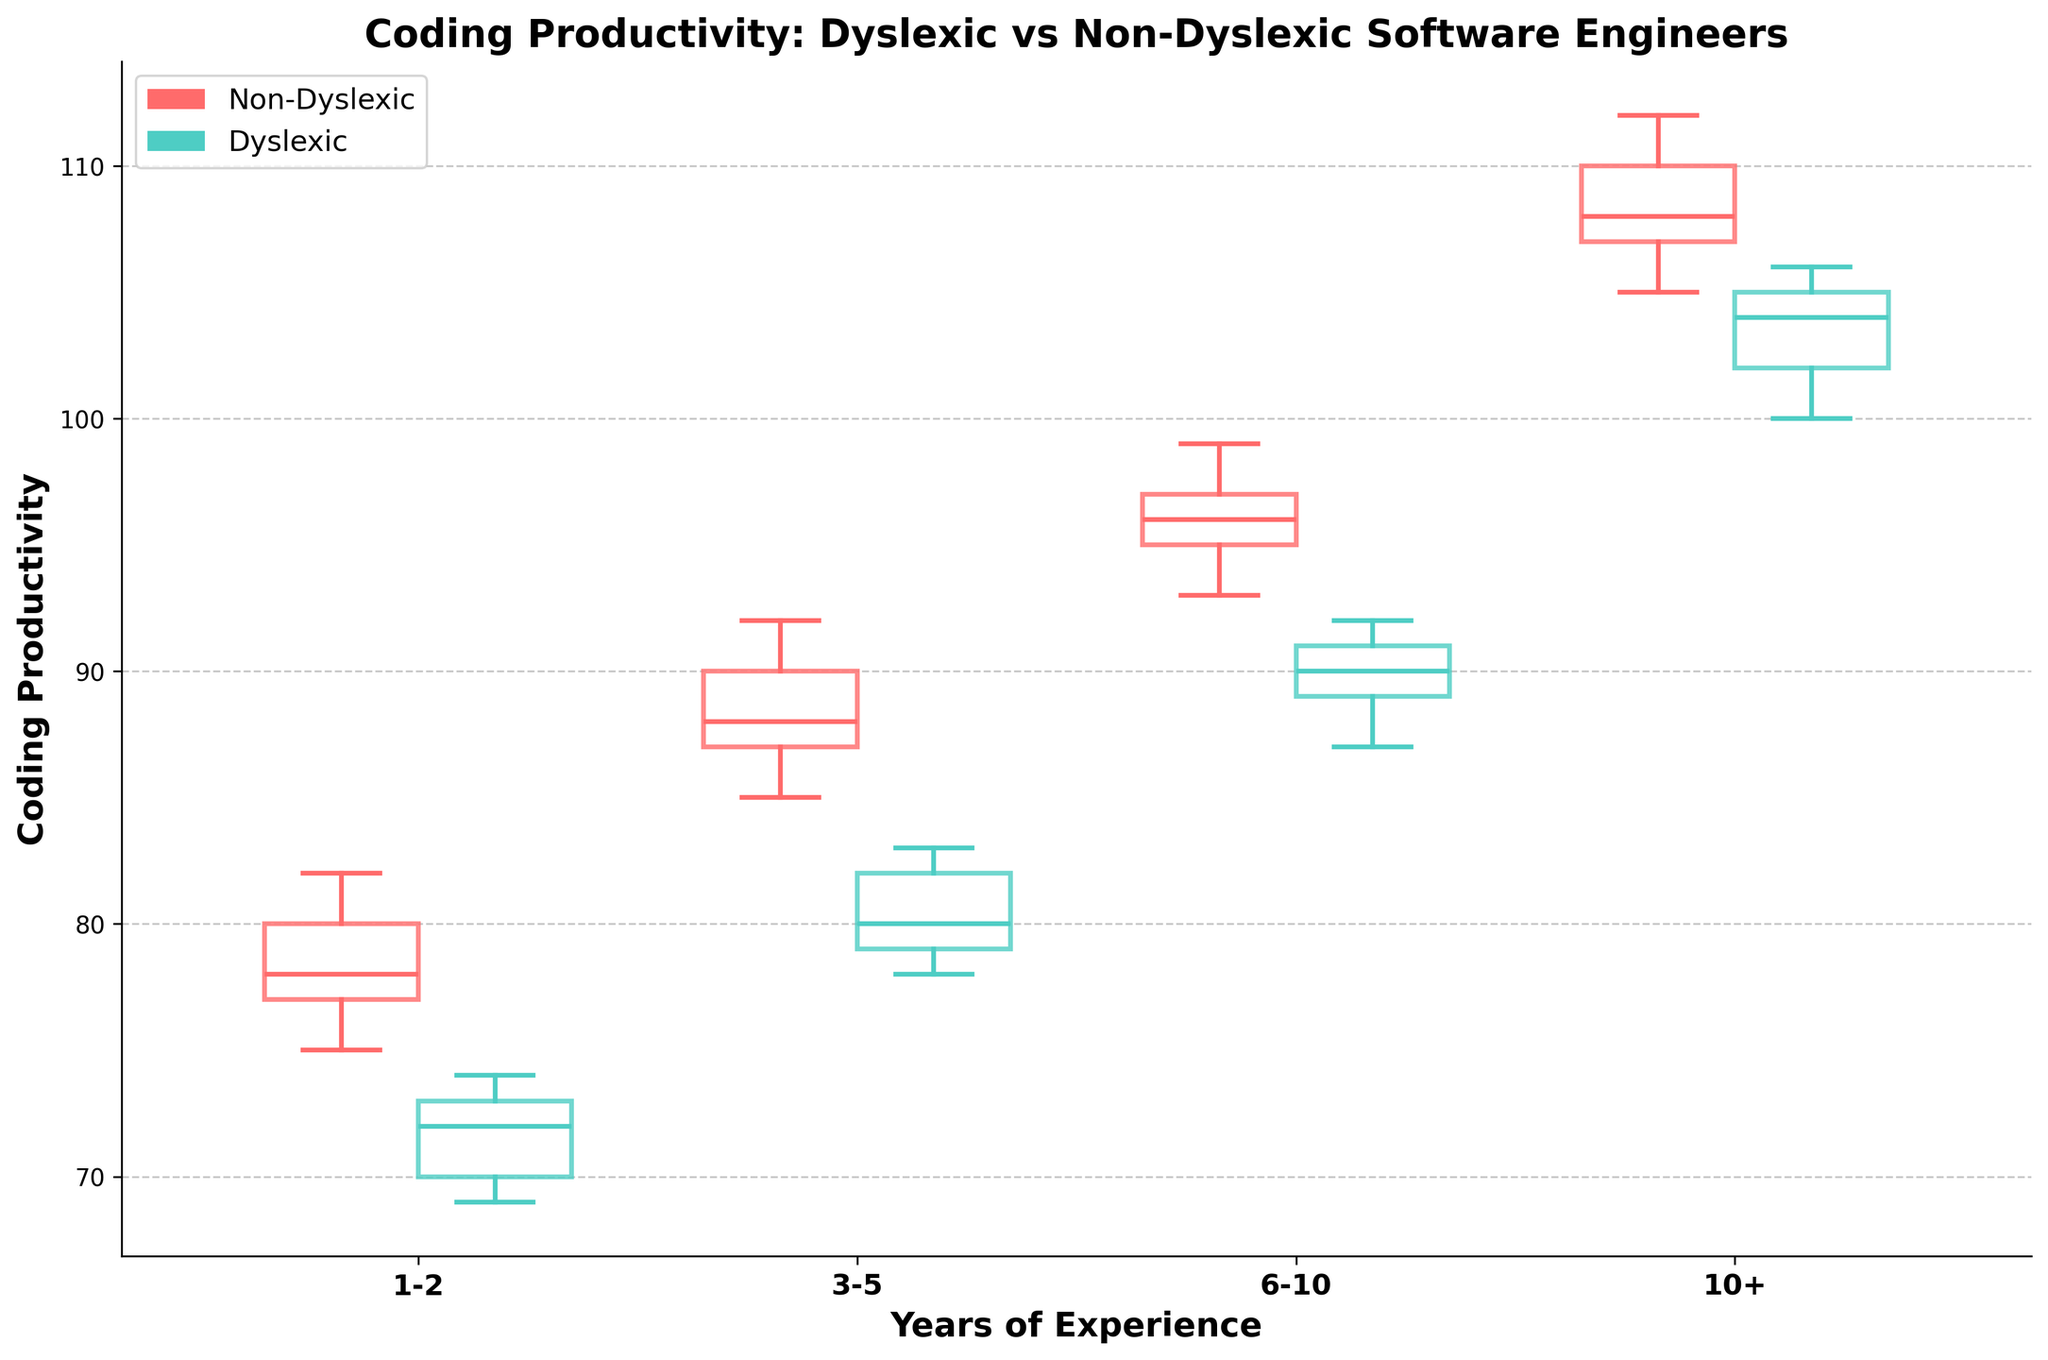How many different experience levels are displayed in the plot? The x-axis contains categories for years of experience. By counting the distinct labels on the x-axis, we find there are four different experience levels.
Answer: Four Which group has the higher median productivity for the 1-2 years experience level? To find the median productivity for each group, look at the line in the middle of each box plot. For the 1-2 years experience level, the Non-Dyslexic group median is higher.
Answer: Non-Dyslexic What is the overall trend in coding productivity with increasing experience for non-dyslexic engineers? Analyze the position of the box plots for non-dyslexic engineers. The median values increase consistently from the 1-2 years to the 10+ years experience levels.
Answer: Increasing Is there any experience level where dyslexic engineers have higher productivity than non-dyslexic engineers? Compare the median lines of the box plots for each experience level. For each level, the Non-Dyslexic group's median is higher than the Dyslexic group's median.
Answer: No Which group shows a greater variance in productivity for the 6-10 years experience level? Variance in productivity is indicated by the size of the box and the length of the whiskers. For the 6-10 years experience level, the Non-Dyslexic group has a larger box and whiskers than the Dyslexic group, indicating greater variance.
Answer: Non-Dyslexic What is the average productivity for dyslexic engineers with 10+ years of experience? To calculate the average, sum the productivity values for dyslexic engineers with 10+ years of experience: 100 + 104 + 102 + 106 + 105 = 517. Then divide by the number of data points: 517 / 5 = 103.4.
Answer: 103.4 How does the productivity interquartile range (IQR) for dyslexic engineers with 3-5 years of experience compare to non-dyslexic engineers with the same experience? IQR is the distance between the first quartile (Q1) and the third quartile (Q3). Estimate the IQRs visually for 3-5 years experience: Dyslexic engineers have a smaller IQR than Non-Dyslexic engineers.
Answer: Smaller At which experience level is the gap in median productivity between dyslexic and non-dyslexic engineers the smallest? Compare the gaps between the median lines across all experience levels. The smallest gap is observed at the 10+ years experience level.
Answer: 10+ years 